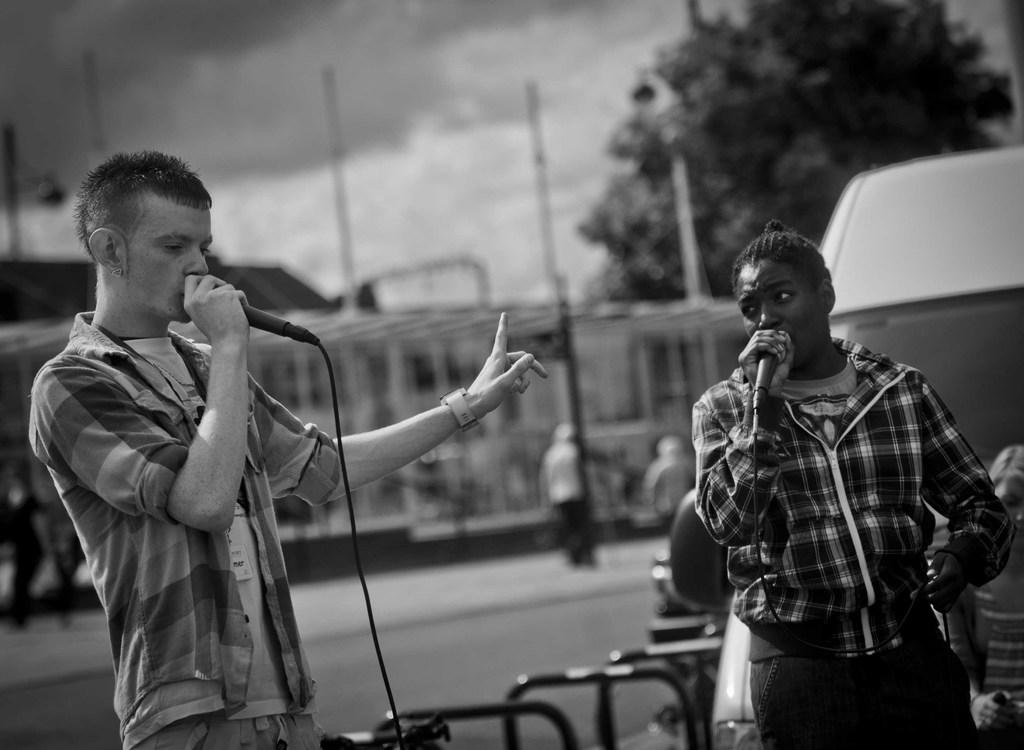What is the color scheme of the image? The image is black and white. What are the two people in the image doing? They are holding microphones near their mouths. Can you describe the background of the image? The background is blurred, and there are people and a tree visible in the background. What else can be seen in the background of the image? The sky is visible in the background. What other object is present in the image? There is a vehicle in the image. What type of yarn is being used to join the two people together in the image? There is no yarn present in the image, and the two people are not joined together. 